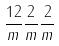Convert formula to latex. <formula><loc_0><loc_0><loc_500><loc_500>\frac { 1 2 } { m } \frac { 2 } { m } \frac { 2 } { m }</formula> 